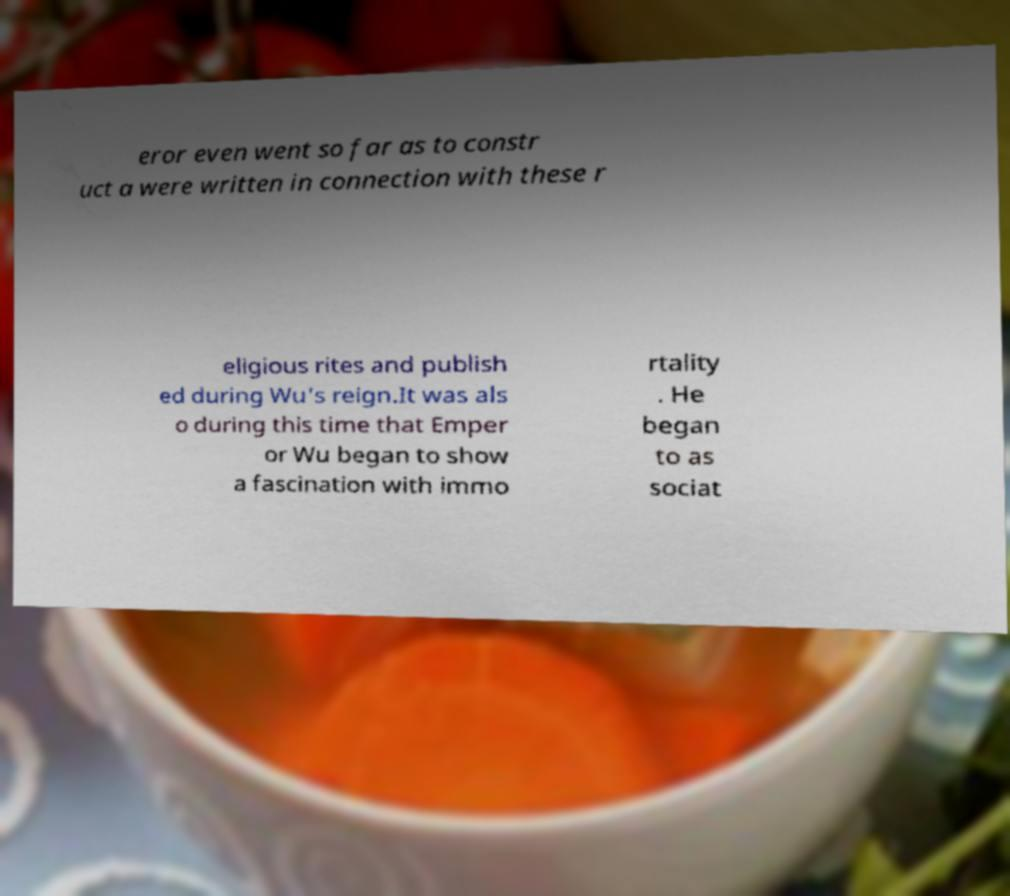Please identify and transcribe the text found in this image. eror even went so far as to constr uct a were written in connection with these r eligious rites and publish ed during Wu's reign.It was als o during this time that Emper or Wu began to show a fascination with immo rtality . He began to as sociat 